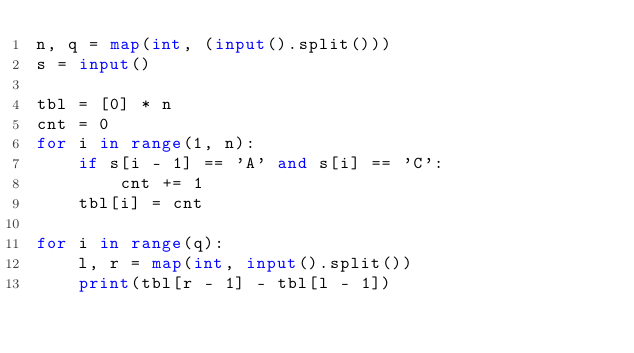<code> <loc_0><loc_0><loc_500><loc_500><_Python_>n, q = map(int, (input().split()))
s = input()

tbl = [0] * n
cnt = 0
for i in range(1, n):
    if s[i - 1] == 'A' and s[i] == 'C':
        cnt += 1
    tbl[i] = cnt

for i in range(q):
    l, r = map(int, input().split())
    print(tbl[r - 1] - tbl[l - 1])
</code> 